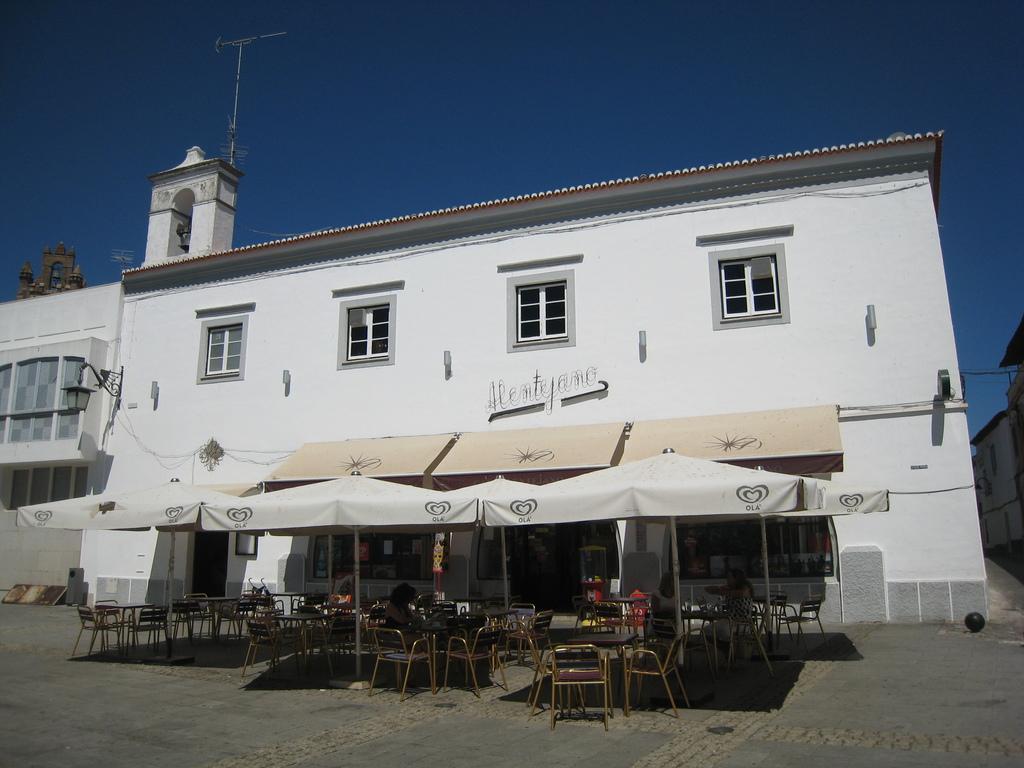Please provide a concise description of this image. In this image I can see few buildings,windows,chairs,light pole,tables,few stores and few umbrellas. The sky is in blue color. 